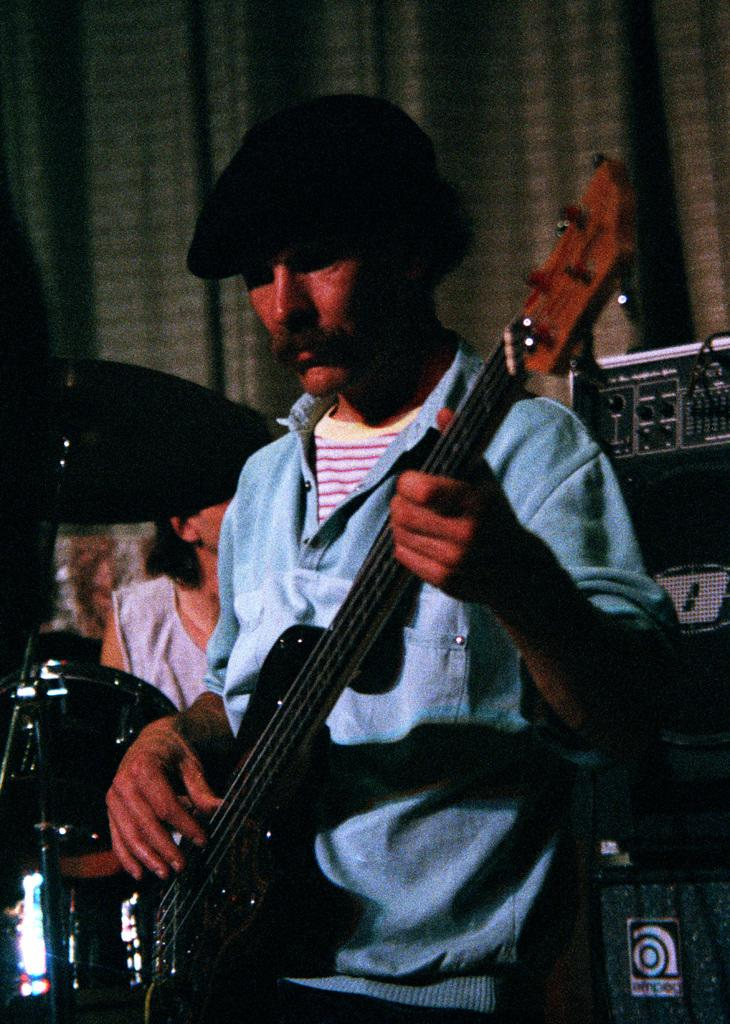Who is the main subject in the image? There is a man in the center of the image. What is the man holding in his hand? The man is holding a guitar in his hand. Can you describe the man's attire? The man is wearing a cap. What can be seen in the background of the image? There is a band, speakers, and a curtain in the background of the image. What type of goose is sitting on the curtain in the image? There is no goose present in the image; it only features a man holding a guitar, a band in the background, speakers, and a curtain. 